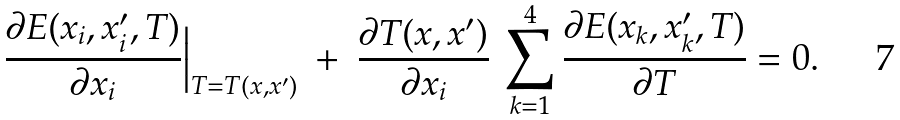Convert formula to latex. <formula><loc_0><loc_0><loc_500><loc_500>\frac { \partial E ( x _ { i } , x _ { i } ^ { \prime } , T ) } { \partial x _ { i } } \Big | _ { T = T ( x , x ^ { \prime } ) } \ + \ \frac { \partial T ( x , x ^ { \prime } ) } { \partial x _ { i } } \ \sum _ { k = 1 } ^ { 4 } \frac { \partial E ( x _ { k } , x _ { k } ^ { \prime } , T ) } { \partial T } = 0 .</formula> 